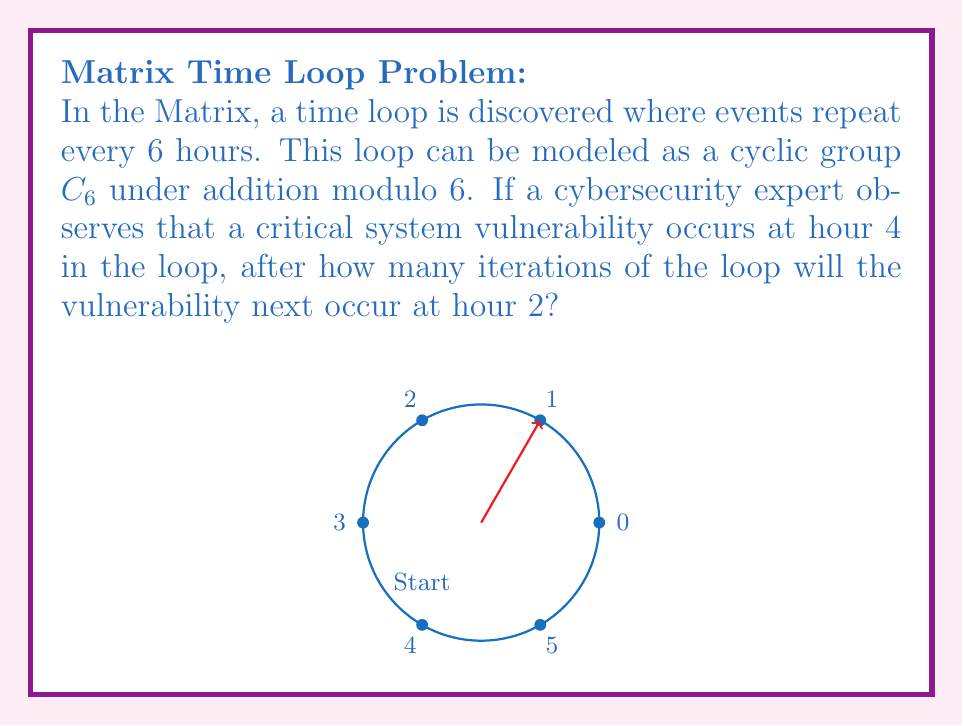Help me with this question. Let's approach this step-by-step:

1) In the cyclic group $C_6$, we can represent the hours as elements {0, 1, 2, 3, 4, 5}.

2) The vulnerability occurs at hour 4 initially. We need to find how many iterations it takes to reach hour 2.

3) Mathematically, we're looking for the smallest positive integer $n$ such that:

   $$(4 + n) \equiv 2 \pmod{6}$$

4) This is equivalent to solving:

   $$n \equiv -2 \pmod{6}$$

5) In modular arithmetic, this is the same as:

   $$n \equiv 4 \pmod{6}$$

6) The smallest positive $n$ that satisfies this is 4.

7) We can verify: $(4 + 4) \bmod 6 = 8 \bmod 6 = 2$

Therefore, after 4 iterations of the loop, the vulnerability will occur at hour 2.
Answer: 4 iterations 